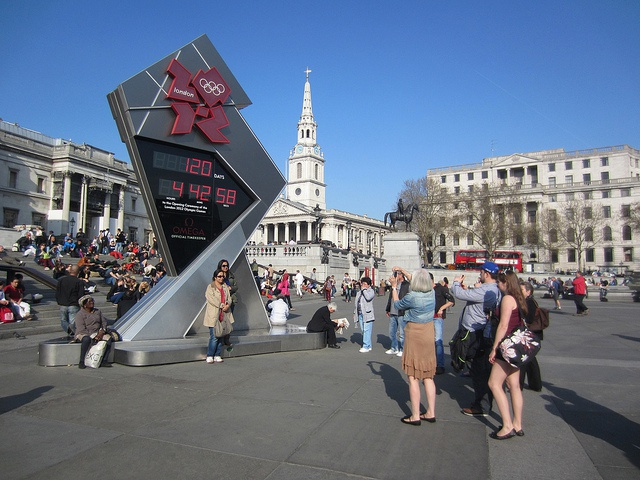Describe the objects in this image and their specific colors. I can see people in blue, black, gray, darkgray, and lightgray tones, clock in blue, black, darkblue, and gray tones, people in blue, tan, gray, and darkgray tones, people in blue, tan, black, gray, and maroon tones, and people in blue, black, darkgray, gray, and navy tones in this image. 